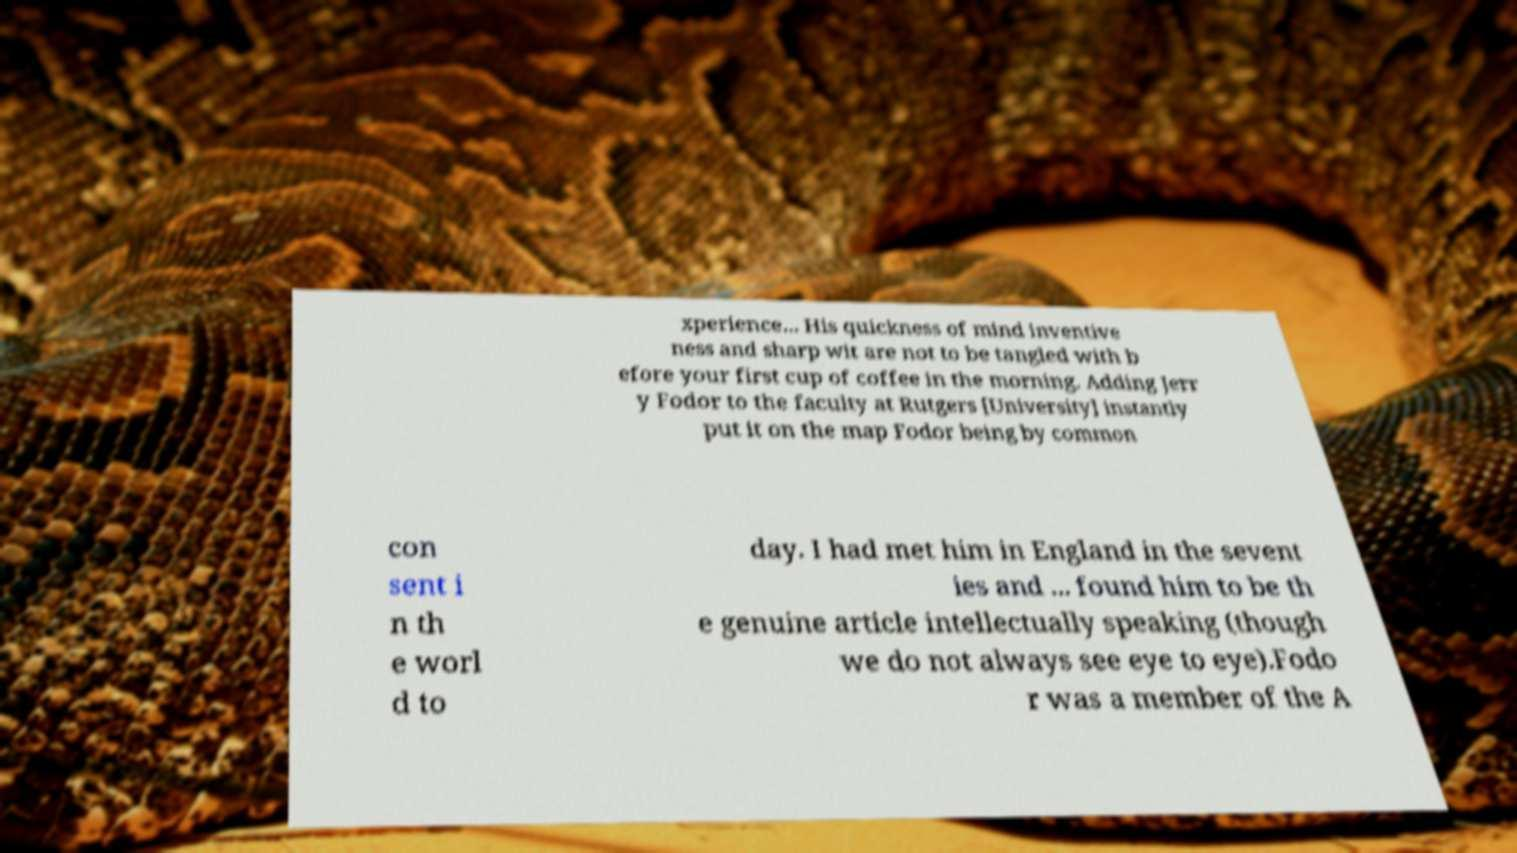Can you accurately transcribe the text from the provided image for me? xperience... His quickness of mind inventive ness and sharp wit are not to be tangled with b efore your first cup of coffee in the morning. Adding Jerr y Fodor to the faculty at Rutgers [University] instantly put it on the map Fodor being by common con sent i n th e worl d to day. I had met him in England in the sevent ies and ... found him to be th e genuine article intellectually speaking (though we do not always see eye to eye).Fodo r was a member of the A 